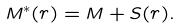Convert formula to latex. <formula><loc_0><loc_0><loc_500><loc_500>M ^ { \ast } ( { r } ) = M + S ( { r } ) .</formula> 